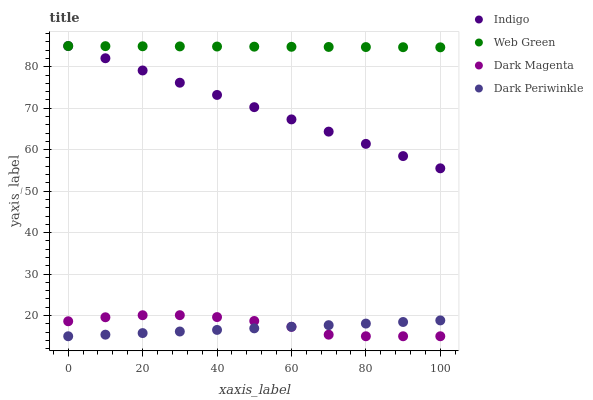Does Dark Periwinkle have the minimum area under the curve?
Answer yes or no. Yes. Does Web Green have the maximum area under the curve?
Answer yes or no. Yes. Does Dark Magenta have the minimum area under the curve?
Answer yes or no. No. Does Dark Magenta have the maximum area under the curve?
Answer yes or no. No. Is Dark Periwinkle the smoothest?
Answer yes or no. Yes. Is Dark Magenta the roughest?
Answer yes or no. Yes. Is Web Green the smoothest?
Answer yes or no. No. Is Web Green the roughest?
Answer yes or no. No. Does Dark Magenta have the lowest value?
Answer yes or no. Yes. Does Web Green have the lowest value?
Answer yes or no. No. Does Web Green have the highest value?
Answer yes or no. Yes. Does Dark Magenta have the highest value?
Answer yes or no. No. Is Dark Magenta less than Indigo?
Answer yes or no. Yes. Is Indigo greater than Dark Magenta?
Answer yes or no. Yes. Does Dark Periwinkle intersect Dark Magenta?
Answer yes or no. Yes. Is Dark Periwinkle less than Dark Magenta?
Answer yes or no. No. Is Dark Periwinkle greater than Dark Magenta?
Answer yes or no. No. Does Dark Magenta intersect Indigo?
Answer yes or no. No. 